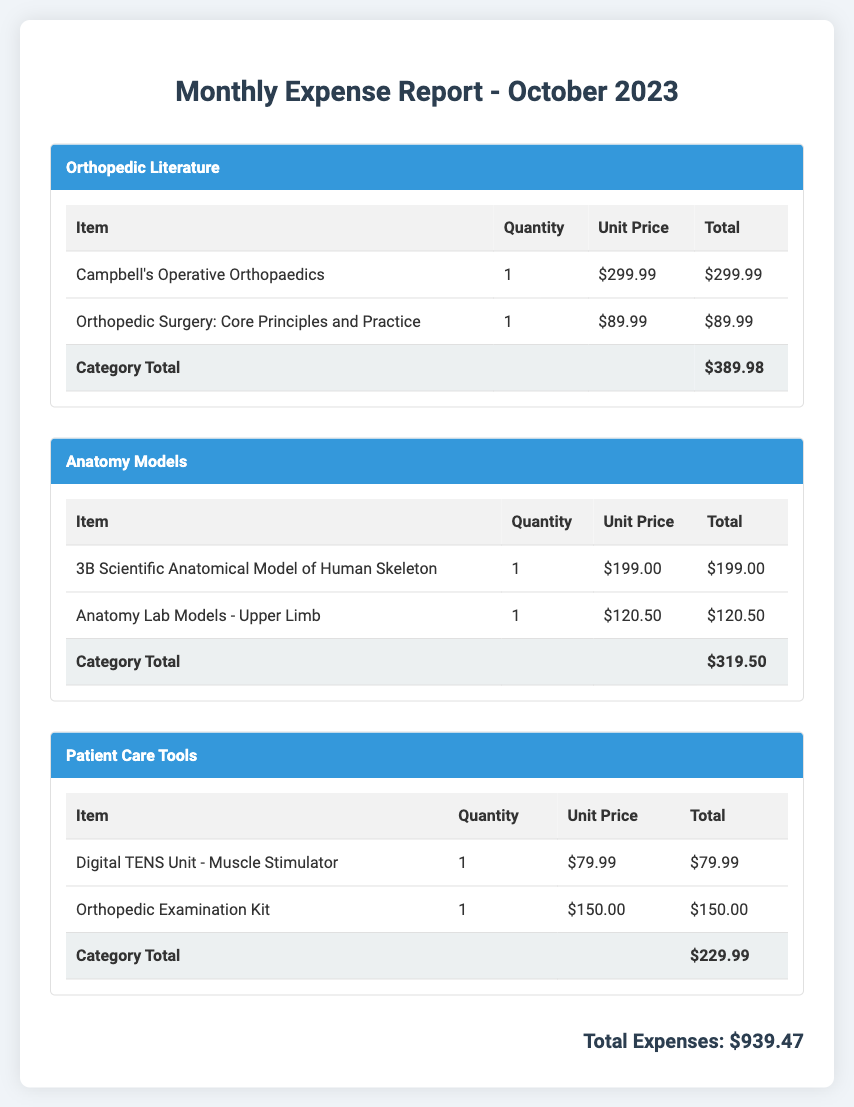What is the total expense for Orthopedic Literature? The category total for Orthopedic Literature is listed at the bottom of the section, which is $389.98.
Answer: $389.98 What is the unit price of the 3B Scientific Anatomical Model of Human Skeleton? The unit price for this item is printed in the table under the Anatomy Models section as $199.00.
Answer: $199.00 How many total items were purchased for Patient Care Tools? There are two items listed in the Patient Care Tools category, indicated by the quantity column in the table.
Answer: 2 What is the grand total of all expenses? The grand total is summarized at the bottom of the document, which is $939.47.
Answer: $939.47 Which textbook costs $89.99? The document specifies that "Orthopedic Surgery: Core Principles and Practice" costs $89.99 in the Orthopedic Literature category.
Answer: Orthopedic Surgery: Core Principles and Practice What is the total for Anatomy Models? The total for the Anatomy Models category is provided at the end of the section, which sums up to $319.50.
Answer: $319.50 How much does the Orthopedic Examination Kit cost? The cost for the Orthopedic Examination Kit is specified as $150.00 in the Patient Care Tools section of the document.
Answer: $150.00 What is the total amount spent on Anatomy Lab Models - Upper Limb? The total for this specific item is shown in the table as $120.50.
Answer: $120.50 